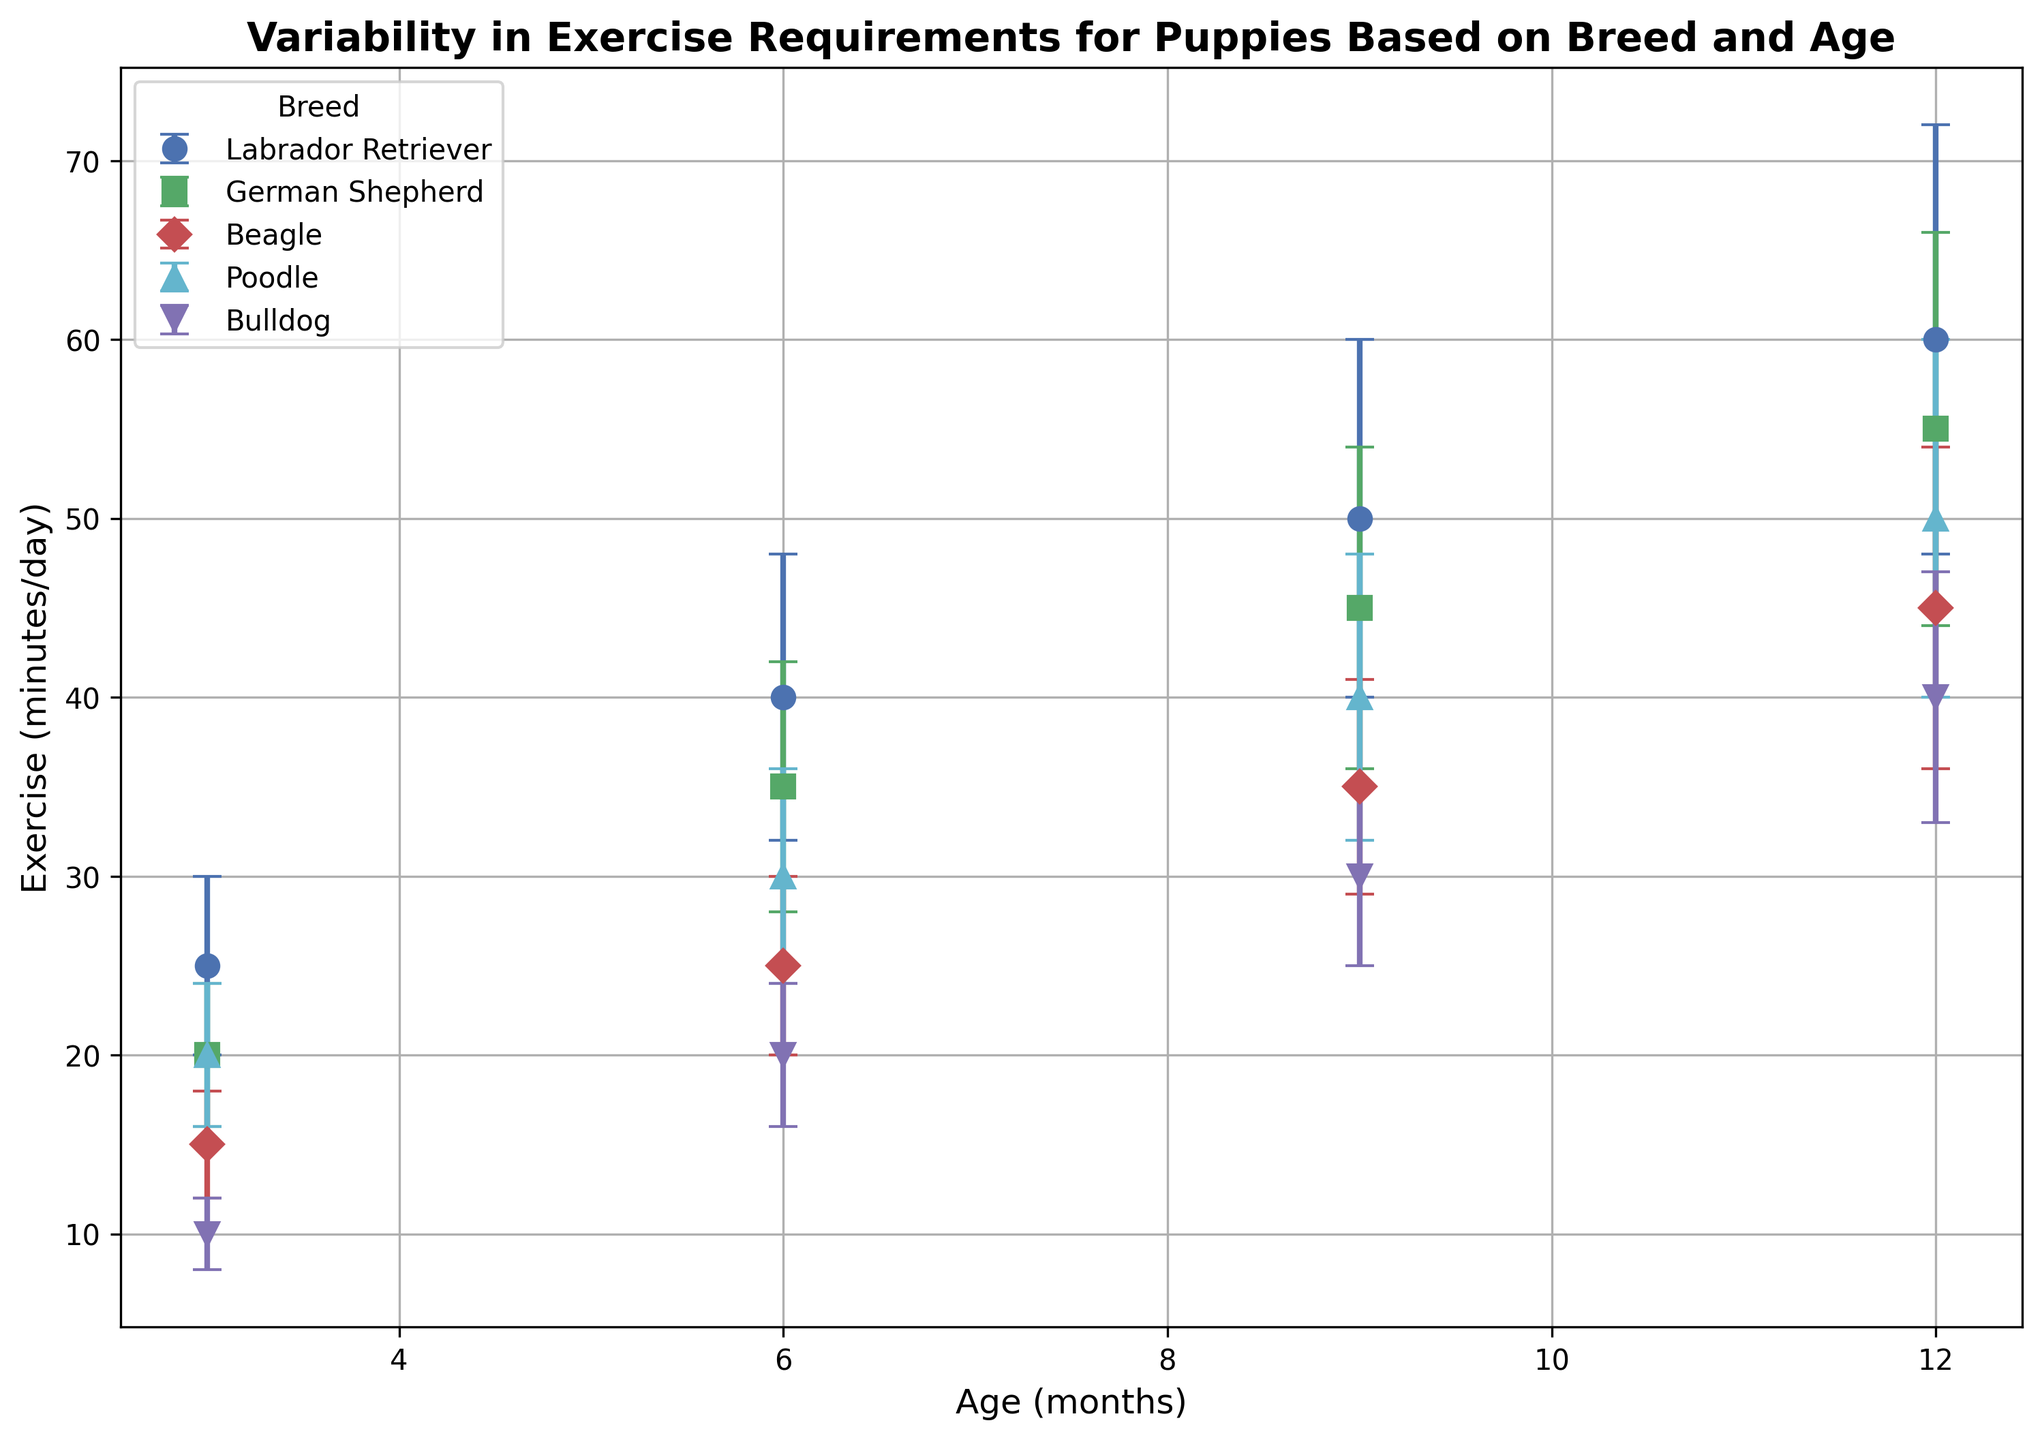Which breed requires the least amount of exercise at 3 months? Among the breeds shown for 3 months, the Bulldog requires the least amount of exercise. The visual representation indicates it has the lowest value on the exercise axis.
Answer: Bulldog How does the exercise requirement of a German Shepherd at 6 months compare to that of a Beagle at 6 months? Examination of the figure shows that the German Shepherd requires 35 minutes/day of exercise whereas the Beagle requires 25 minutes/day.
Answer: German Shepherd has a higher requirement What is the difference in exercise requirements between a Labrador Retriever and a Poodle at 12 months? At 12 months, the Labrador Retriever requires 60 minutes/day, while the Poodle requires 50 minutes/day. The difference is 60 - 50 = 10.
Answer: 10 minutes Which breed shows the highest increase in exercise requirements from 3 months to 12 months? The Labrador Retriever increases from 25 minutes/day at 3 months to 60 minutes/day at 12 months, an increase of 35. Comparing this with other breeds shows it is the highest increase.
Answer: Labrador Retriever What is the average exercise requirement for the Bulldog across all ages shown? The Bulldog requires 10, 20, 30, and 40 minutes/day at 3, 6, 9, and 12 months, respectively. The average is (10 + 20 + 30 + 40) / 4 = 25.
Answer: 25 minutes/day Among the breeds shown, which has the largest variability (standard deviation) in exercise requirements at 9 months? The Labrador Retriever has the largest standard deviation at 9 months, with an error bar indicating 10 minutes.
Answer: Labrador Retriever Which breed requires the most exercise at 6 months, and how much more is it compared to the Bulldog of the same age? The Labrador Retriever requires 40 minutes/day at 6 months, while the Bulldog requires 20 minutes/day. The difference is 40 - 20 = 20.
Answer: Labrador Retriever, 20 minutes more Is there any breed that shows a consistent increase in exercise requirements without variability across different ages? No, all breeds exhibit some degree of variability (as indicated by error bars) in their exercise requirements across different ages.
Answer: No By examining the error bars, which breed shows the least uncertainty (smallest average error bars) in exercise requirements? The Beagle has relatively smaller error bars across the ages when compared to other breeds, indicating less variability in exercise requirements.
Answer: Beagle 